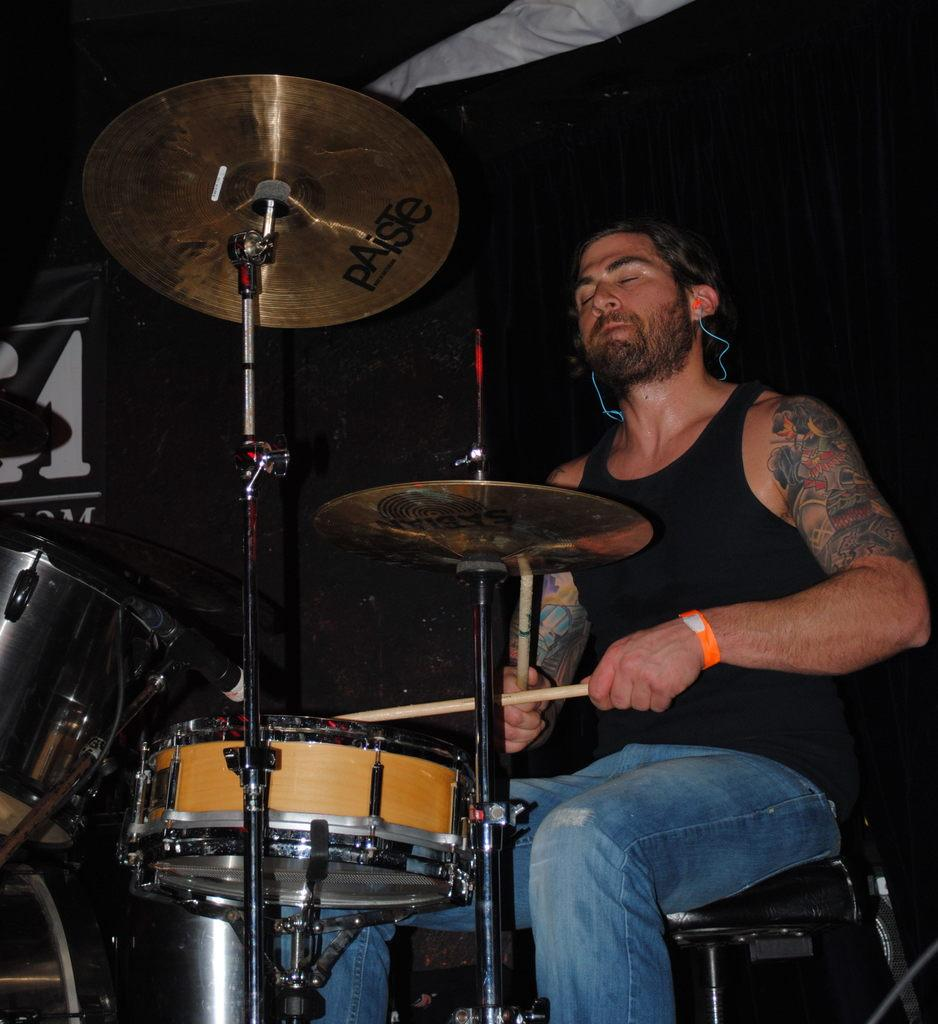What is the person in the image doing? The person is sitting on a chair in the image. What is the person holding in the image? The person is holding sticks in the image. What else can be seen in the image besides the person? There are musical instruments visible in the image. What is the color of the background in the image? The background of the image is black. How many boats can be seen at the seashore in the image? There are no boats or seashore present in the image. 